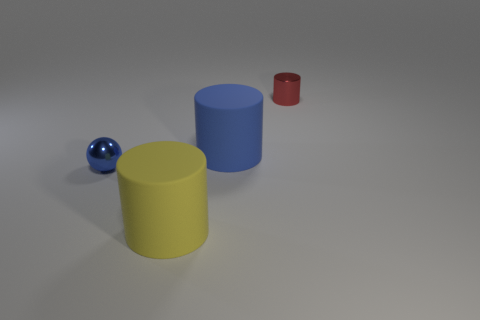Can you describe the colors of the objects in the image? Certainly! There is a blue cylinder, a yellow cylinder, a small red cylinder, and a shiny blue metal ball. Which object seems to reflect the most light? The shiny blue metal ball appears to reflect the most light, indicating its polished metal texture. 